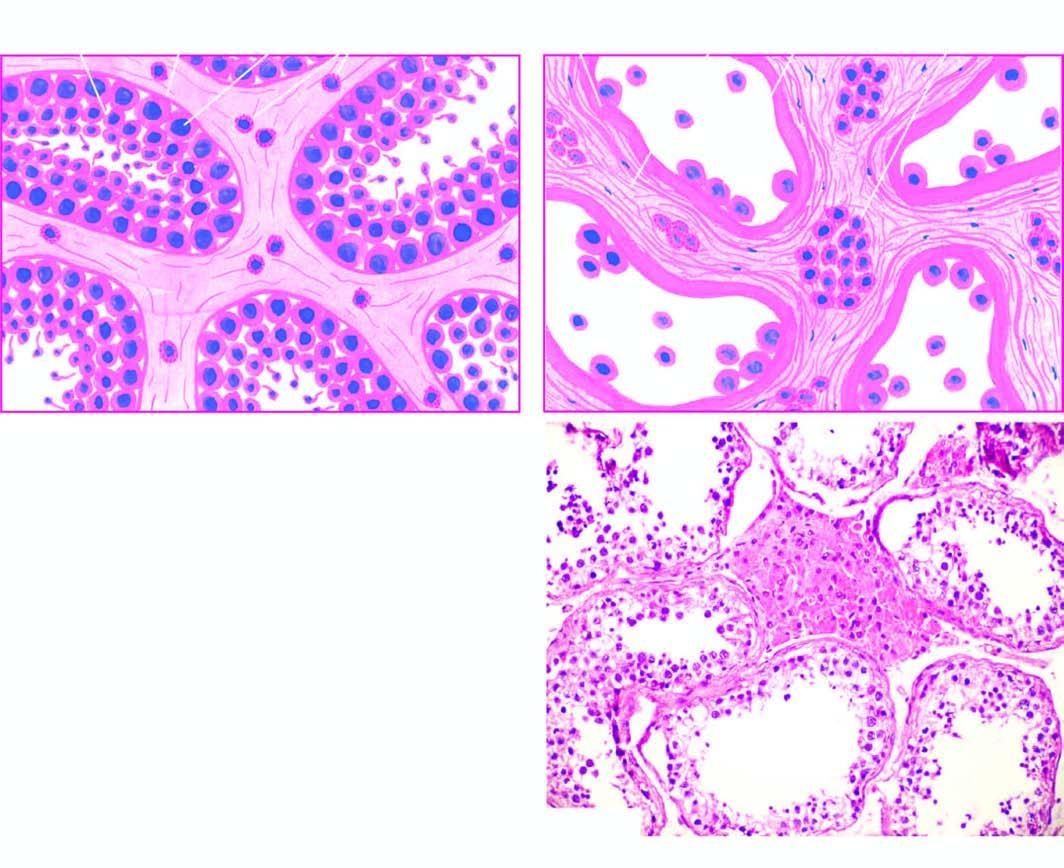s microscopic appearance of normal testis contrasted with that of cryptorchid testis?
Answer the question using a single word or phrase. Yes 